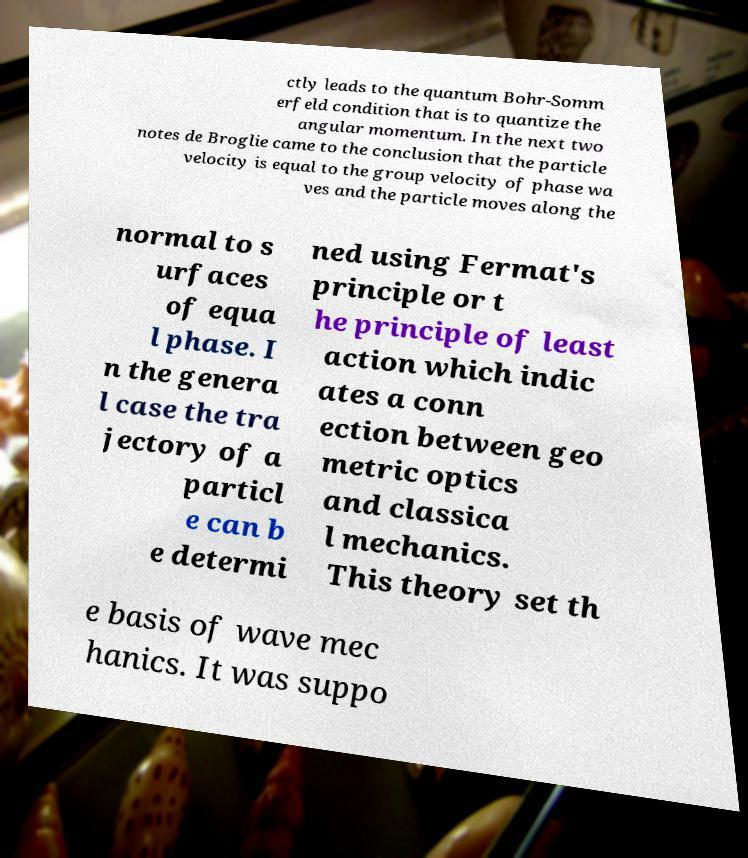For documentation purposes, I need the text within this image transcribed. Could you provide that? ctly leads to the quantum Bohr-Somm erfeld condition that is to quantize the angular momentum. In the next two notes de Broglie came to the conclusion that the particle velocity is equal to the group velocity of phase wa ves and the particle moves along the normal to s urfaces of equa l phase. I n the genera l case the tra jectory of a particl e can b e determi ned using Fermat's principle or t he principle of least action which indic ates a conn ection between geo metric optics and classica l mechanics. This theory set th e basis of wave mec hanics. It was suppo 